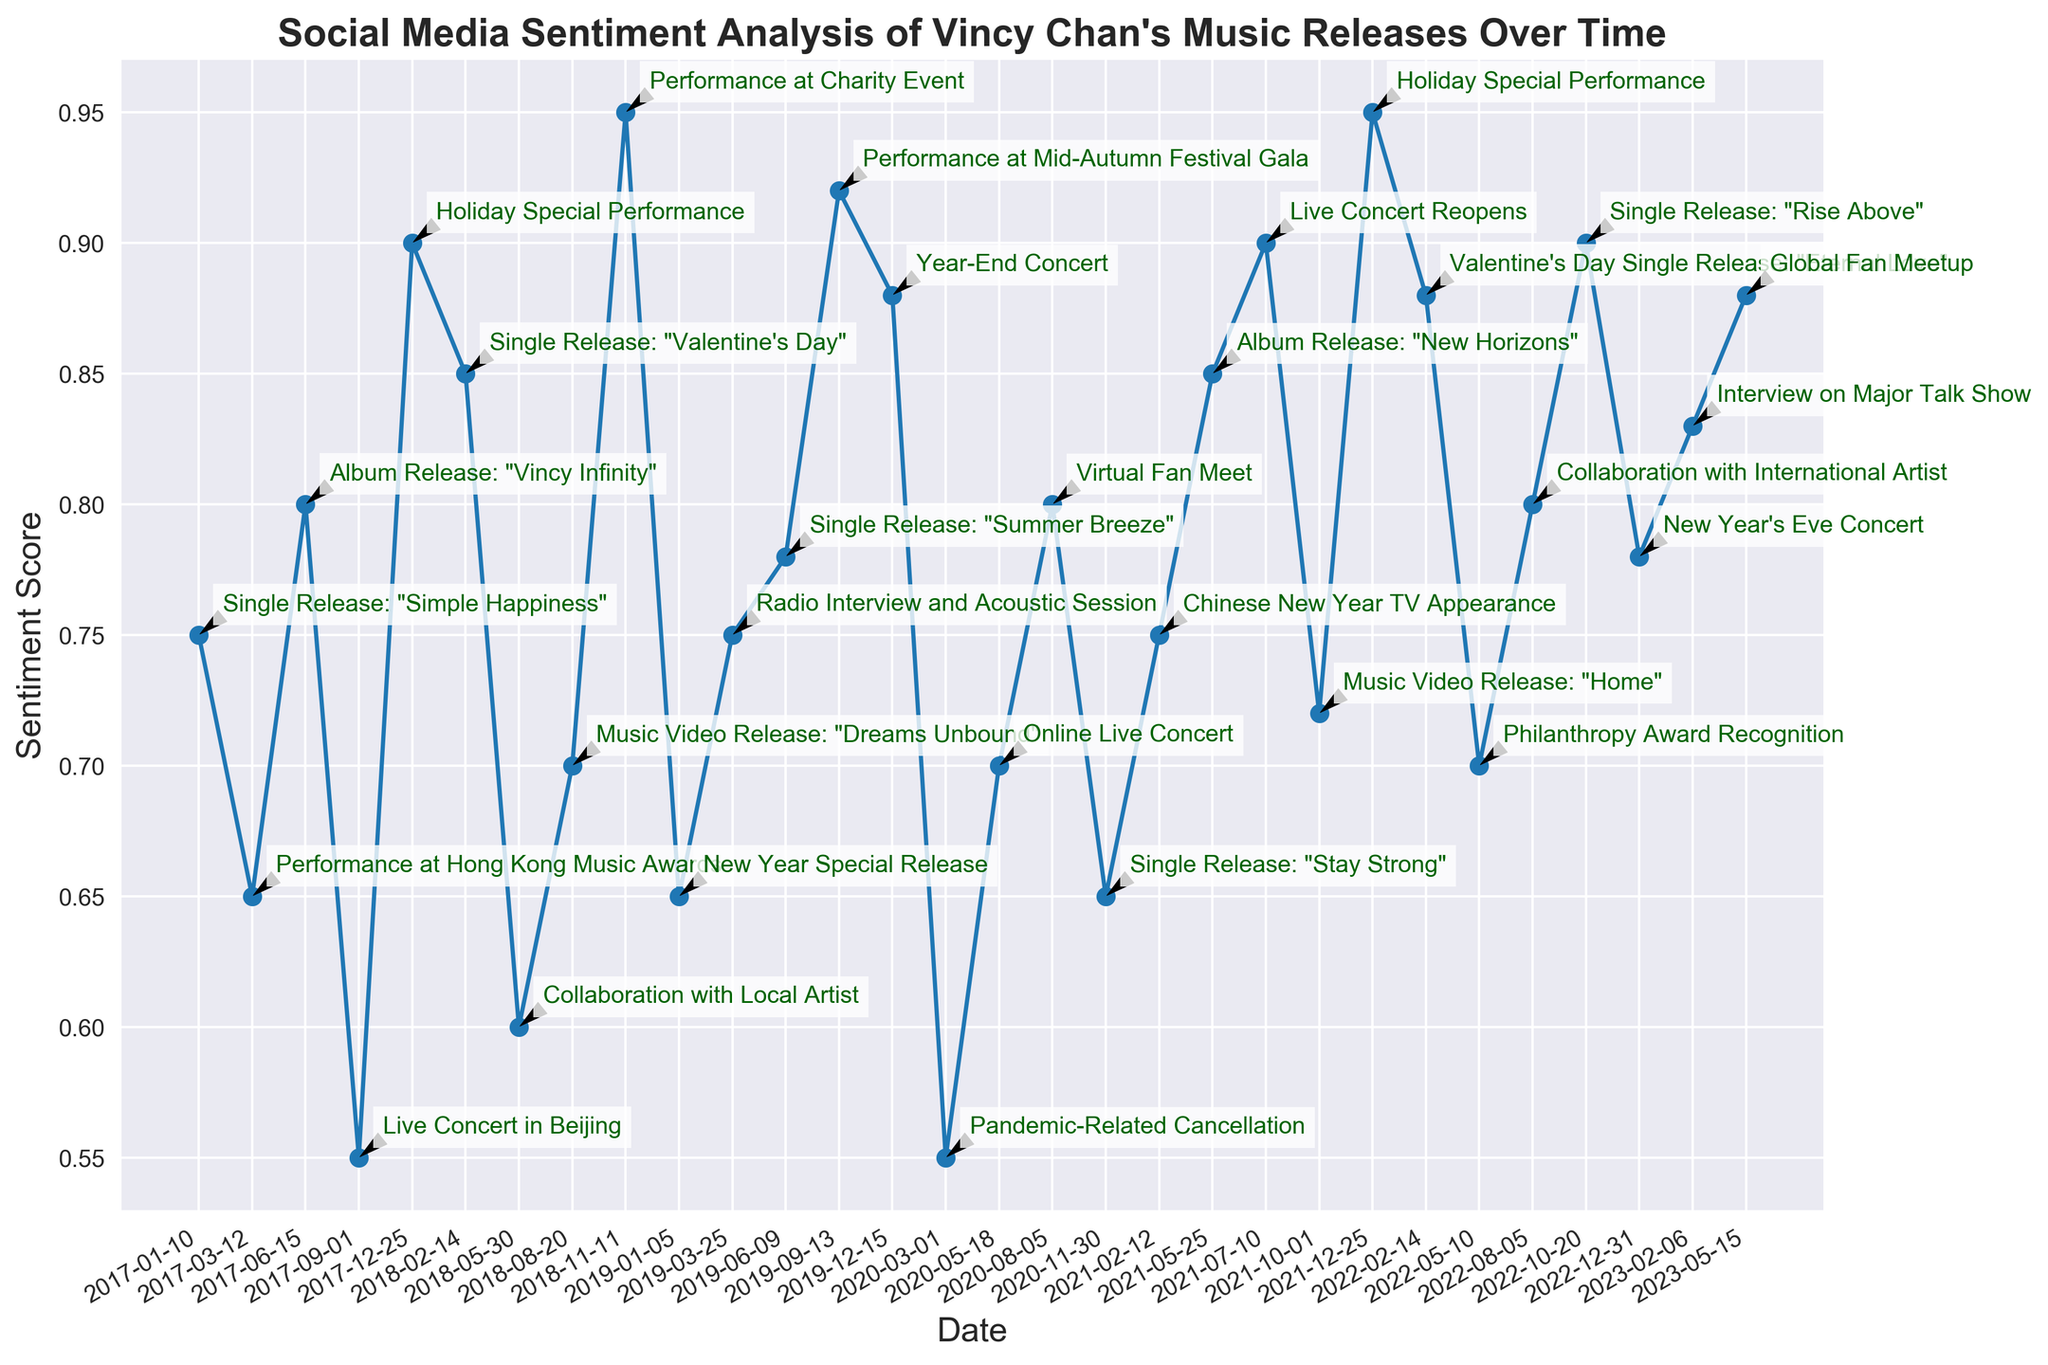What is the highest sentiment score observed in the chart? The highest sentiment score can be found by scanning the sentiment score values plotted on the chart. The maximum sentiment score observed is 0.95.
Answer: 0.95 What event corresponds to the lowest sentiment score in the chart? To find this event, locate the lowest point on the plotted sentiment score line and check its corresponding annotation. The lowest sentiment score is 0.55, which corresponds to the "Pandemic-Related Cancellation" on 2020-03-01.
Answer: Pandemic-Related Cancellation Which year shows the highest average sentiment score? Calculate the average sentiment score for each year by summing the sentiment scores and dividing by the number of events each year. Compare these averages to find the highest. 2022 shows the highest average sentiment score.
Answer: 2022 Is there a noticeable trend in sentiment scores around release events versus performances? To determine the trend, observe the sentiment scores associated with release events (e.g., singles and albums) and compare them to those associated with performances. Release events generally show higher sentiment scores compared to performances.
Answer: Releases > Performances Compare the sentiment scores before and after the "Pandemic-Related Cancellation" on 2020-03-01. Is there a significant difference? Analyze the sentiment scores immediately before (e.g., 2019-12-15 with a score of 0.88) and after the indicated event (e.g., 2020-05-18 with a score of 0.70). The sentiment score drops significantly after the "Pandemic-Related Cancellation" event.
Answer: Significant drop How does the sentiment score for "Live Concert Reopens" on 2021-07-10 compare to the average sentiment score for the year 2020? First, determine the sentiment score for "Live Concert Reopens" (0.90). Then, calculate the average sentiment score for 2020 by adding up the scores (0.55, 0.70, 0.80, 0.65) and dividing by the number of events (4). The average for 2020 is 0.675. Compare these two values.
Answer: Higher What is the trend in sentiment scores between two consecutive Holiday Special Performances? Compare the sentiment scores for the "Holiday Special Performance" on 2017-12-25 (0.90) and the same event on 2021-12-25 (0.95). The sentiment scores have increased.
Answer: Increasing trend 